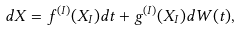Convert formula to latex. <formula><loc_0><loc_0><loc_500><loc_500>d X = f ^ { ( I ) } ( X _ { I } ) d t + g ^ { ( I ) } ( X _ { I } ) d W ( t ) ,</formula> 